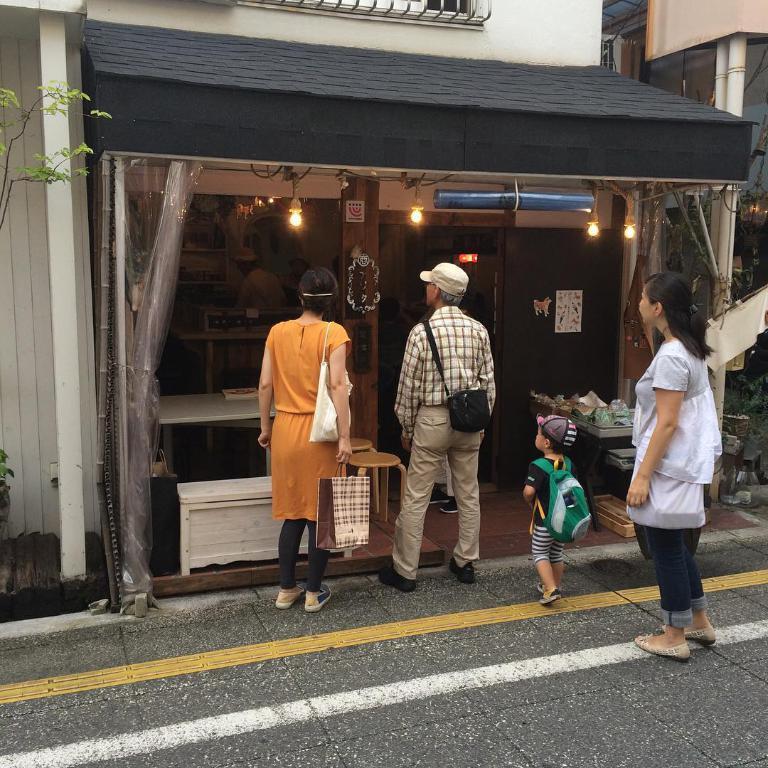How would you summarize this image in a sentence or two? In this picture I can see few people standing and a boy walking. I can see a store, few lights and another building on the right side of the picture and I can see a plant on the left side of the picture. 